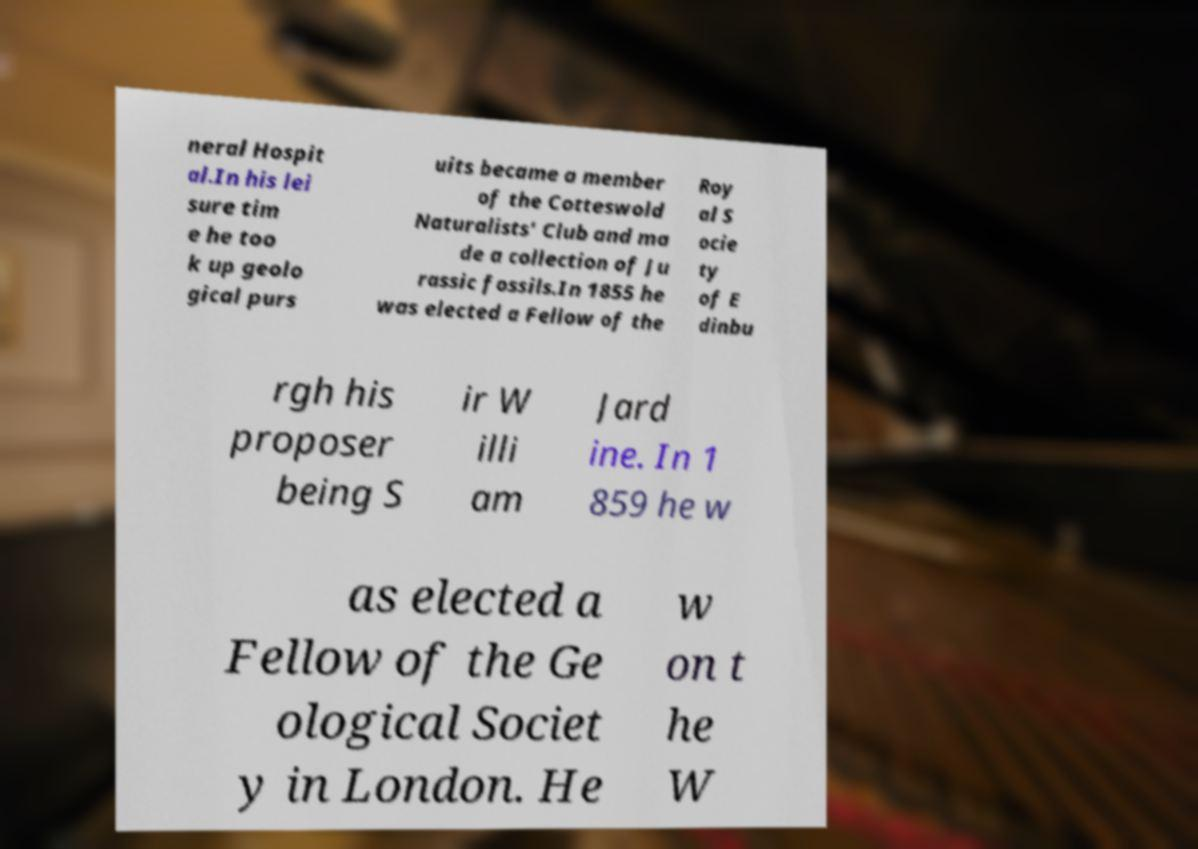There's text embedded in this image that I need extracted. Can you transcribe it verbatim? neral Hospit al.In his lei sure tim e he too k up geolo gical purs uits became a member of the Cotteswold Naturalists' Club and ma de a collection of Ju rassic fossils.In 1855 he was elected a Fellow of the Roy al S ocie ty of E dinbu rgh his proposer being S ir W illi am Jard ine. In 1 859 he w as elected a Fellow of the Ge ological Societ y in London. He w on t he W 